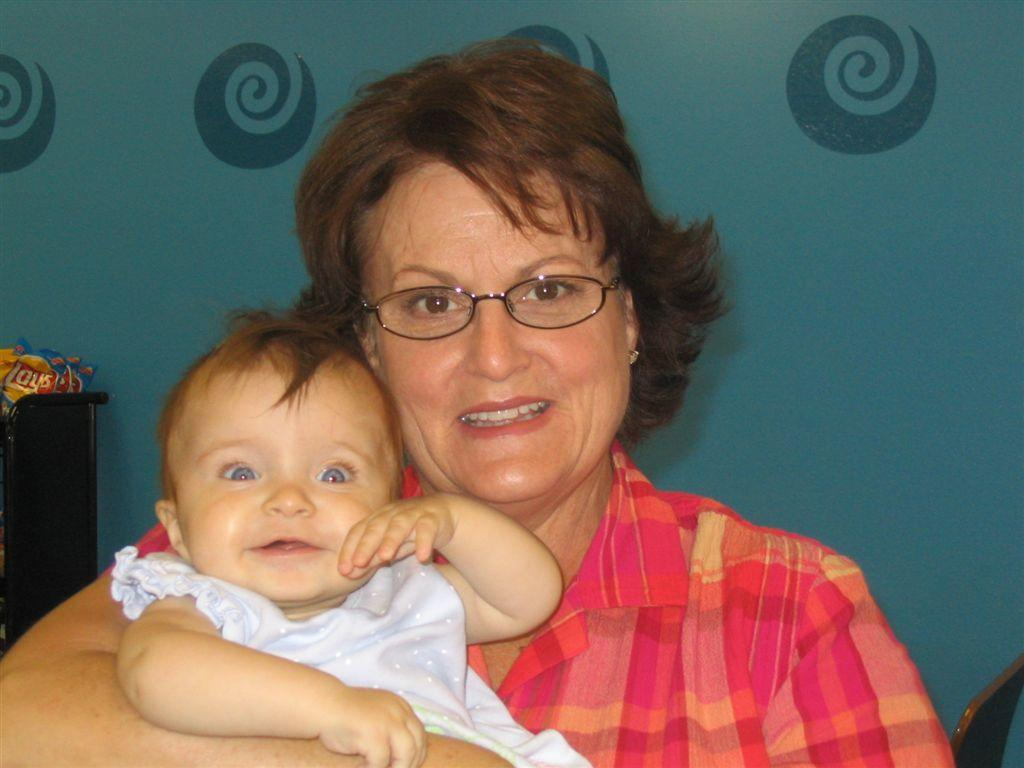What is the main subject of the image? The main subject of the image is a woman. What is the woman doing in the image? The woman is holding a baby in the image. Where is the woman and baby located in the image? The woman and baby are in the center of the image. What can be seen in the background of the image? There is a wall in the background of the image. What type of meat is the woman cooking for the baby in the image? There is no indication in the image that the woman is cooking or that there is any meat present. What idea does the woman have for the baby's future in the image? There is no information provided in the image to suggest the woman has any specific ideas for the baby's future. Is there a donkey visible in the image? No, there is no donkey present in the image. 